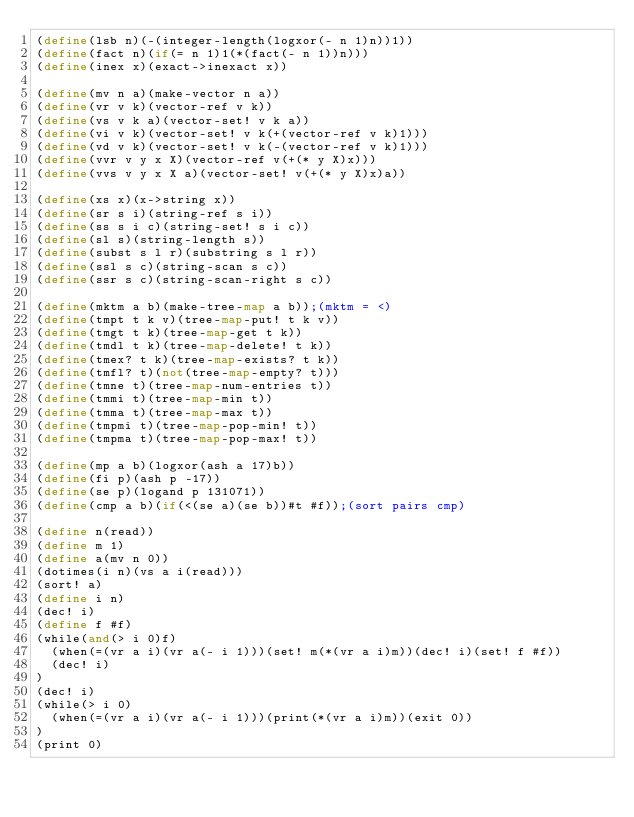<code> <loc_0><loc_0><loc_500><loc_500><_Scheme_>(define(lsb n)(-(integer-length(logxor(- n 1)n))1))
(define(fact n)(if(= n 1)1(*(fact(- n 1))n)))
(define(inex x)(exact->inexact x))

(define(mv n a)(make-vector n a))
(define(vr v k)(vector-ref v k))
(define(vs v k a)(vector-set! v k a))
(define(vi v k)(vector-set! v k(+(vector-ref v k)1)))
(define(vd v k)(vector-set! v k(-(vector-ref v k)1)))
(define(vvr v y x X)(vector-ref v(+(* y X)x)))
(define(vvs v y x X a)(vector-set! v(+(* y X)x)a))

(define(xs x)(x->string x))
(define(sr s i)(string-ref s i))
(define(ss s i c)(string-set! s i c))
(define(sl s)(string-length s))
(define(subst s l r)(substring s l r))
(define(ssl s c)(string-scan s c))
(define(ssr s c)(string-scan-right s c))

(define(mktm a b)(make-tree-map a b));(mktm = <)
(define(tmpt t k v)(tree-map-put! t k v))
(define(tmgt t k)(tree-map-get t k))
(define(tmdl t k)(tree-map-delete! t k))
(define(tmex? t k)(tree-map-exists? t k))
(define(tmfl? t)(not(tree-map-empty? t)))
(define(tmne t)(tree-map-num-entries t))
(define(tmmi t)(tree-map-min t))
(define(tmma t)(tree-map-max t))
(define(tmpmi t)(tree-map-pop-min! t))
(define(tmpma t)(tree-map-pop-max! t))

(define(mp a b)(logxor(ash a 17)b))
(define(fi p)(ash p -17))
(define(se p)(logand p 131071))
(define(cmp a b)(if(<(se a)(se b))#t #f));(sort pairs cmp)

(define n(read))
(define m 1)
(define a(mv n 0))
(dotimes(i n)(vs a i(read)))
(sort! a)
(define i n)
(dec! i)
(define f #f)
(while(and(> i 0)f)
	(when(=(vr a i)(vr a(- i 1)))(set! m(*(vr a i)m))(dec! i)(set! f #f))
	(dec! i)
)
(dec! i)
(while(> i 0)
	(when(=(vr a i)(vr a(- i 1)))(print(*(vr a i)m))(exit 0))
)
(print 0)</code> 